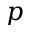<formula> <loc_0><loc_0><loc_500><loc_500>p</formula> 